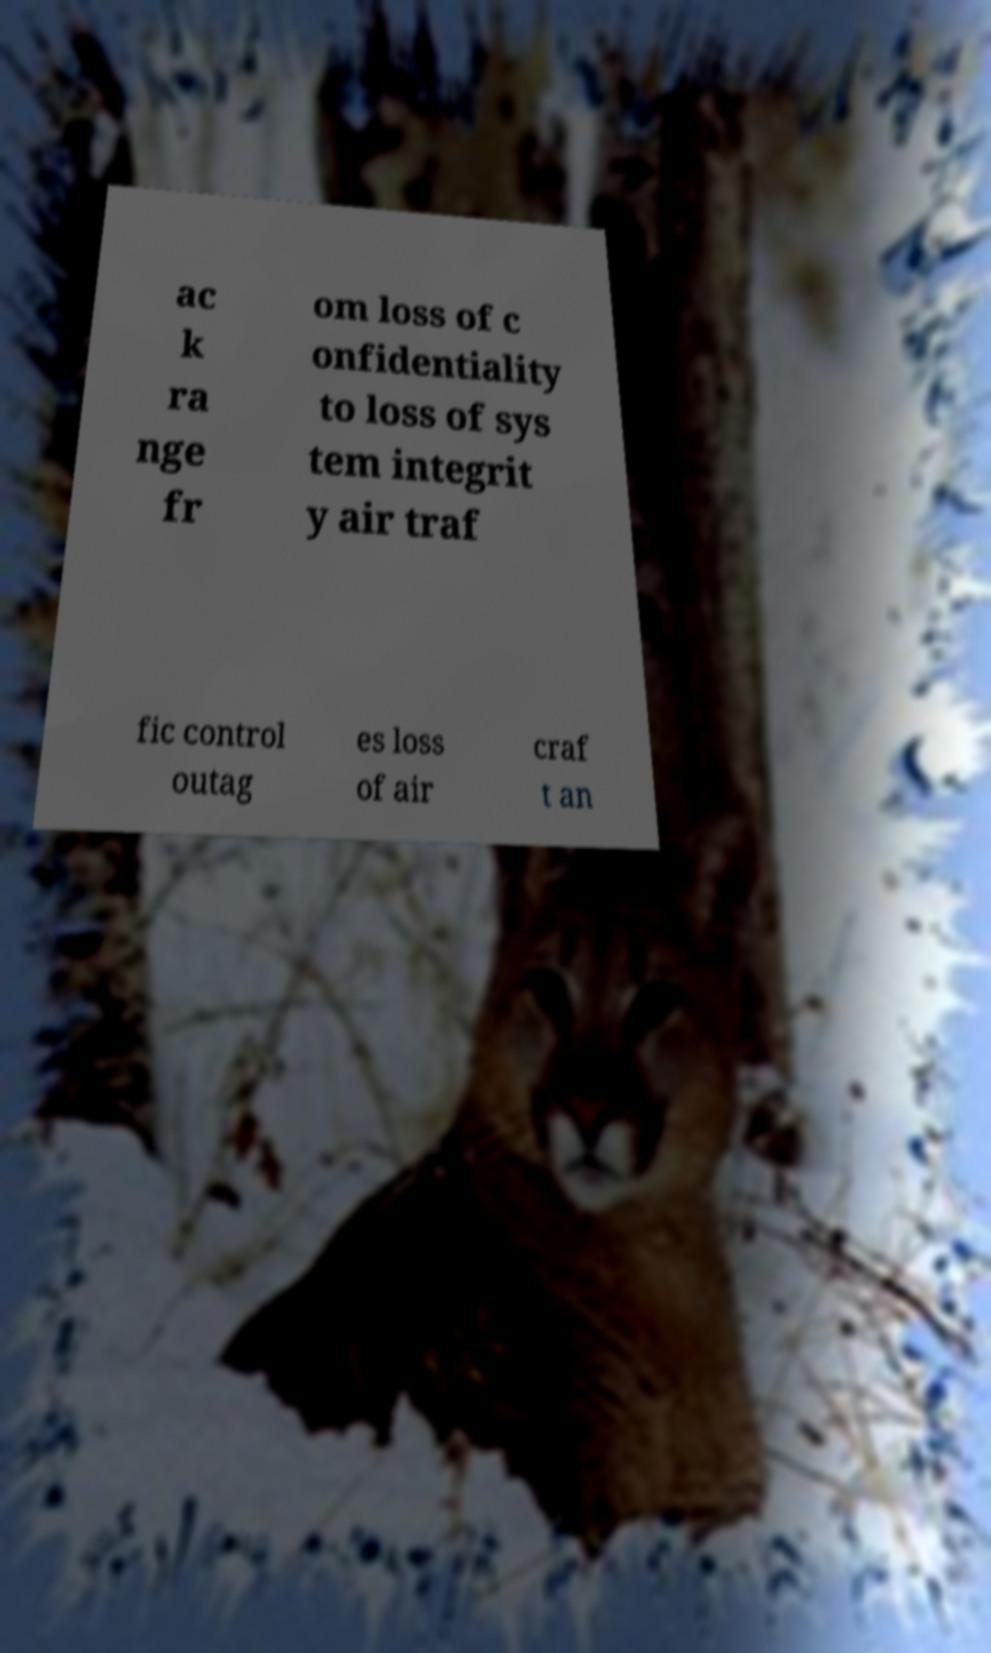There's text embedded in this image that I need extracted. Can you transcribe it verbatim? ac k ra nge fr om loss of c onfidentiality to loss of sys tem integrit y air traf fic control outag es loss of air craf t an 